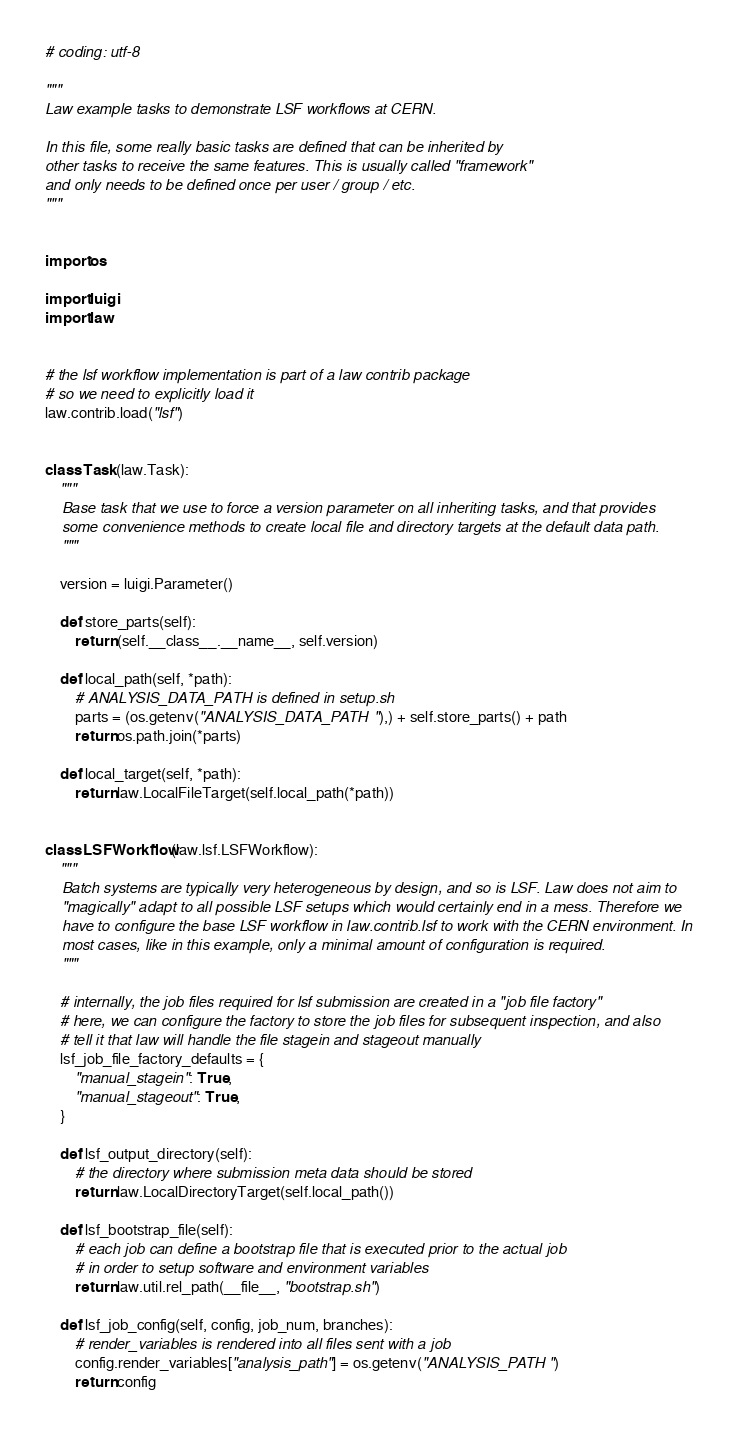Convert code to text. <code><loc_0><loc_0><loc_500><loc_500><_Python_># coding: utf-8

"""
Law example tasks to demonstrate LSF workflows at CERN.

In this file, some really basic tasks are defined that can be inherited by
other tasks to receive the same features. This is usually called "framework"
and only needs to be defined once per user / group / etc.
"""


import os

import luigi
import law


# the lsf workflow implementation is part of a law contrib package
# so we need to explicitly load it
law.contrib.load("lsf")


class Task(law.Task):
    """
    Base task that we use to force a version parameter on all inheriting tasks, and that provides
    some convenience methods to create local file and directory targets at the default data path.
    """

    version = luigi.Parameter()

    def store_parts(self):
        return (self.__class__.__name__, self.version)

    def local_path(self, *path):
        # ANALYSIS_DATA_PATH is defined in setup.sh
        parts = (os.getenv("ANALYSIS_DATA_PATH"),) + self.store_parts() + path
        return os.path.join(*parts)

    def local_target(self, *path):
        return law.LocalFileTarget(self.local_path(*path))


class LSFWorkflow(law.lsf.LSFWorkflow):
    """
    Batch systems are typically very heterogeneous by design, and so is LSF. Law does not aim to
    "magically" adapt to all possible LSF setups which would certainly end in a mess. Therefore we
    have to configure the base LSF workflow in law.contrib.lsf to work with the CERN environment. In
    most cases, like in this example, only a minimal amount of configuration is required.
    """

    # internally, the job files required for lsf submission are created in a "job file factory"
    # here, we can configure the factory to store the job files for subsequent inspection, and also
    # tell it that law will handle the file stagein and stageout manually
    lsf_job_file_factory_defaults = {
        "manual_stagein": True,
        "manual_stageout": True,
    }

    def lsf_output_directory(self):
        # the directory where submission meta data should be stored
        return law.LocalDirectoryTarget(self.local_path())

    def lsf_bootstrap_file(self):
        # each job can define a bootstrap file that is executed prior to the actual job
        # in order to setup software and environment variables
        return law.util.rel_path(__file__, "bootstrap.sh")

    def lsf_job_config(self, config, job_num, branches):
        # render_variables is rendered into all files sent with a job
        config.render_variables["analysis_path"] = os.getenv("ANALYSIS_PATH")
        return config
</code> 